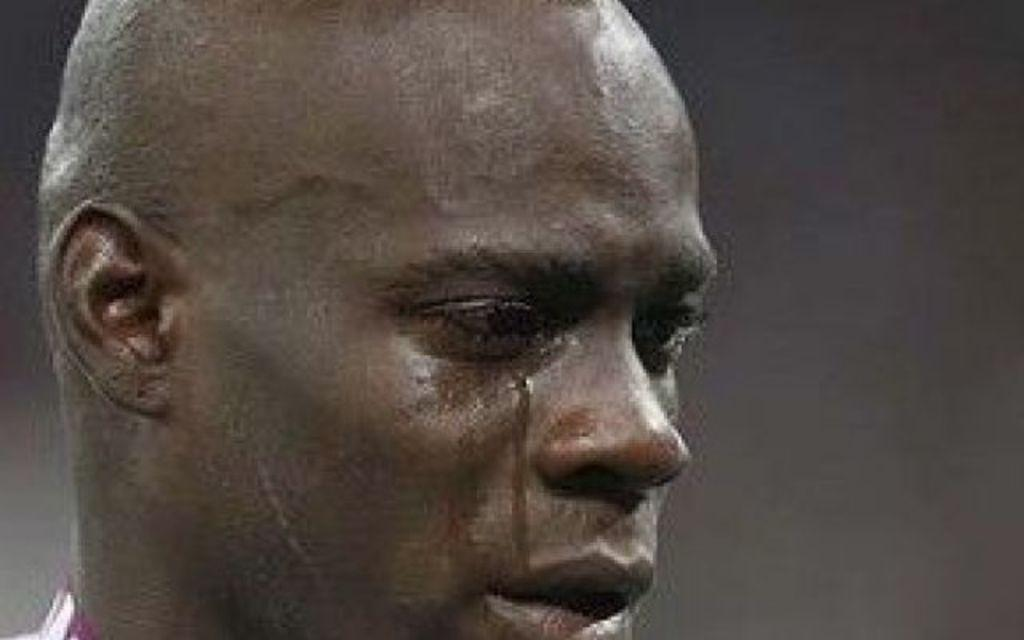What is the main subject of the image? There is a face of a person in the image. What type of flowers can be seen growing behind the curtain in the image? There is no mention of flowers, a curtain, or any other objects in the image besides the face of a person. 